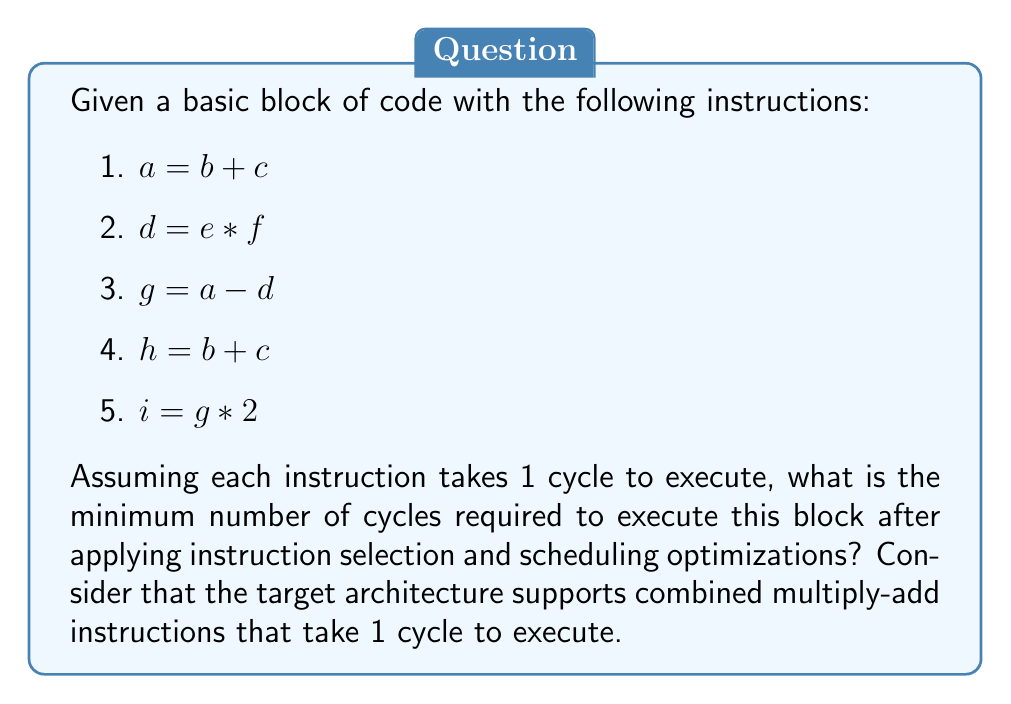Can you solve this math problem? To optimize this code block, we need to apply instruction selection and scheduling techniques:

1. Instruction Selection:
   - Instructions 1 and 4 are identical $(a = b + c)$ and $(h = b + c)$. We can eliminate instruction 4 and use $a$ instead of $h$ in subsequent computations.
   - The target architecture supports combined multiply-add instructions. We can use this to optimize instruction 5 $(i = g * 2)$ by rewriting it as $(i = g + g)$.

2. Instruction Scheduling:
   After applying instruction selection, we have:
   1. $a = b + c$
   2. $d = e * f$
   3. $g = a - d$
   4. $i = g + g$

   Now, we need to schedule these instructions to minimize the number of cycles:
   - Instructions 1 and 2 are independent and can be executed in parallel.
   - Instruction 3 depends on the results of instructions 1 and 2, so it must come after both.
   - Instruction 4 depends on the result of instruction 3.

3. Final optimized schedule:
   Cycle 1: $a = b + c$ and $d = e * f$ (executed in parallel)
   Cycle 2: $g = a - d$
   Cycle 3: $i = g + g$

Therefore, the minimum number of cycles required to execute this optimized block is 3.
Answer: 3 cycles 